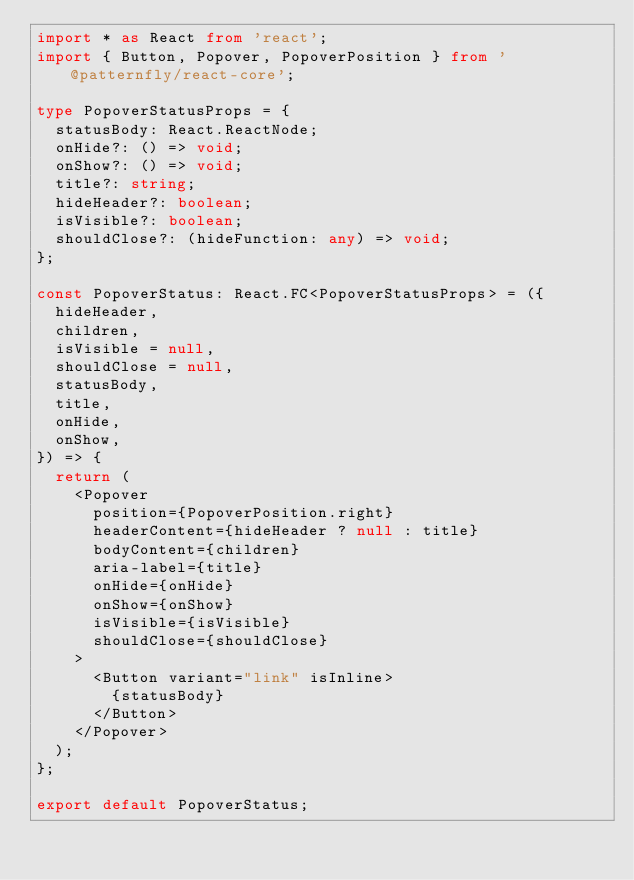<code> <loc_0><loc_0><loc_500><loc_500><_TypeScript_>import * as React from 'react';
import { Button, Popover, PopoverPosition } from '@patternfly/react-core';

type PopoverStatusProps = {
  statusBody: React.ReactNode;
  onHide?: () => void;
  onShow?: () => void;
  title?: string;
  hideHeader?: boolean;
  isVisible?: boolean;
  shouldClose?: (hideFunction: any) => void;
};

const PopoverStatus: React.FC<PopoverStatusProps> = ({
  hideHeader,
  children,
  isVisible = null,
  shouldClose = null,
  statusBody,
  title,
  onHide,
  onShow,
}) => {
  return (
    <Popover
      position={PopoverPosition.right}
      headerContent={hideHeader ? null : title}
      bodyContent={children}
      aria-label={title}
      onHide={onHide}
      onShow={onShow}
      isVisible={isVisible}
      shouldClose={shouldClose}
    >
      <Button variant="link" isInline>
        {statusBody}
      </Button>
    </Popover>
  );
};

export default PopoverStatus;
</code> 